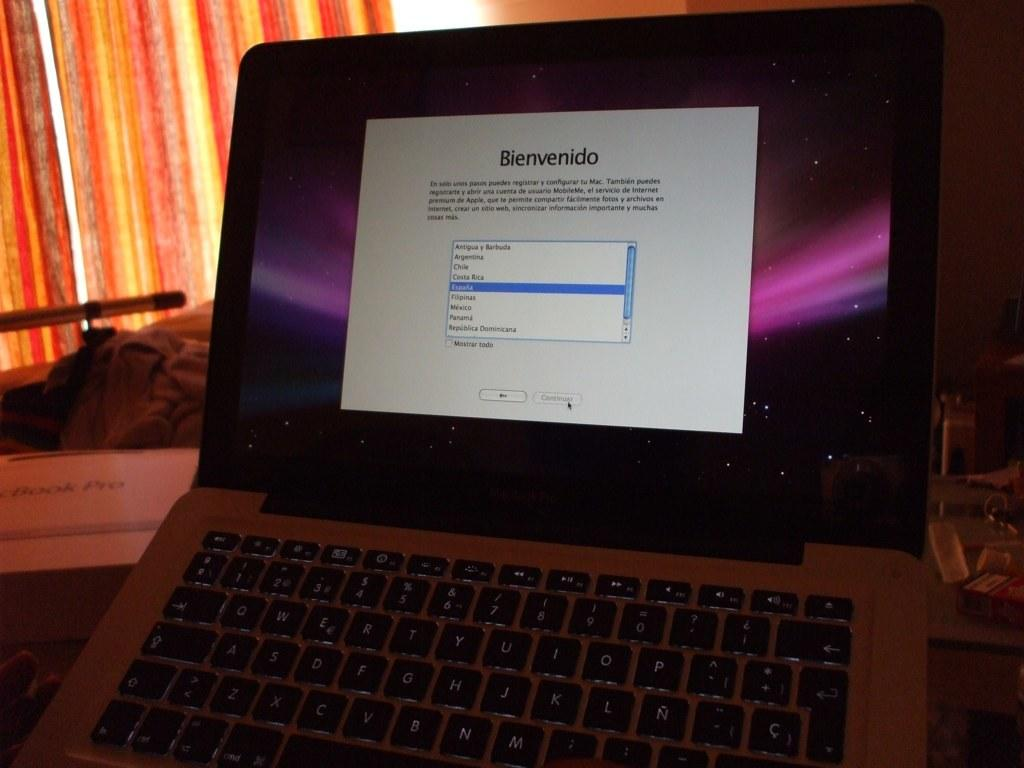<image>
Write a terse but informative summary of the picture. An opened laptop on a desk that says Bienvenido with searches on the screen. 